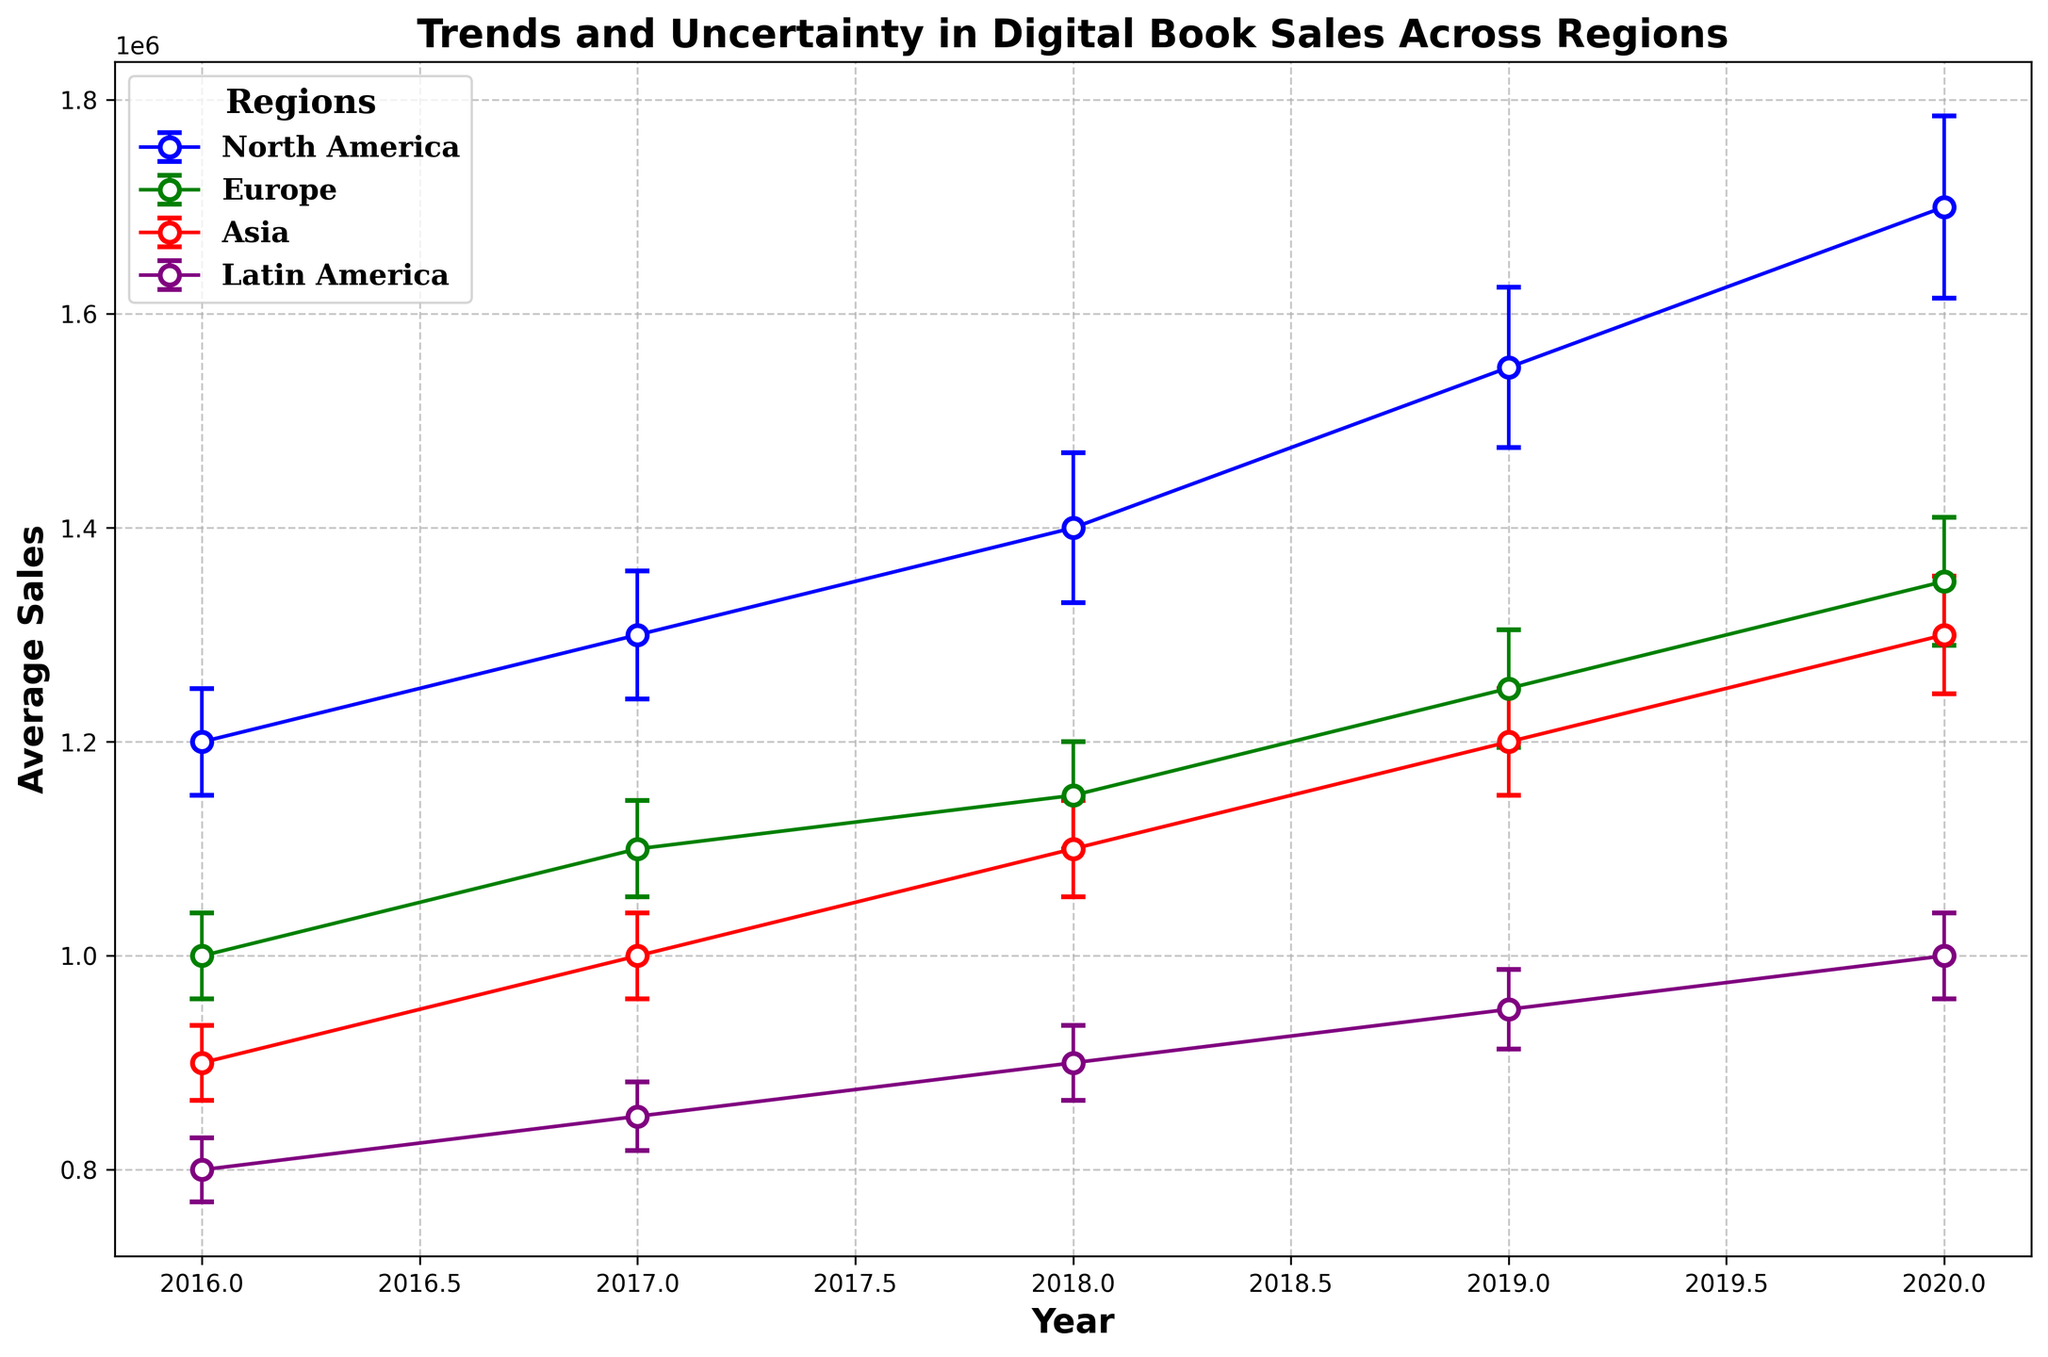How did digital book sales in North America change from 2016 to 2020? North America's sales increased each year from 1,200,000 in 2016 to 1,700,000 in 2020. By examining the figure, you can see a consistent upward trend by following the blue line and marker placement.
Answer: Increased Which region showed the least uncertainty in digital book sales in 2016? By looking at the error bars in the new figure, the region with the smallest uncertainty in 2016 is Latin America, with an error bar length of 30,000. The purple error bar is the shortest for that year compared to others.
Answer: Latin America Did Asia's digital book sales surpass Europe's at any point between 2016 and 2020? By tracking the red line for Asia and the green line for Europe from 2016 to 2020, we see that Europe's sales were consistently higher than Asia's during this period. Consequently, Asia did not surpass Europe in digital book sales.
Answer: No Which year had the highest average uncertainty in digital book sales across all regions? We need to compare the length of error bars for all four regions across the five years. In 2020, North America has 85,000, Europe has 60,000, Asia has 55,000, and Latin America has 40,000, resulting in the highest average uncertainty.
Answer: 2020 What is the difference in average sales between Latin America and North America in 2018? North America's sales in 2018 were 1,400,000, whereas Latin America's were 900,000. Subtracting the two, 1,400,000 - 900,000 gives a difference of 500,000.
Answer: 500,000 Which region experienced the most consistent increase in digital book sales from 2016 to 2020? By examining the trend lines' slopes, Europe's (green) line shows a steady increase with similar increments each year, indicating the most consistent increase.
Answer: Europe What was the trend in digital book sales in Asia from 2016 to 2020, and how did the uncertainty levels change? Asia's sales increased steadily each year from 900,000 to 1,300,000. The uncertainty levels also rose from 35,000 to 55,000, as indicated by increasing error bars on the red line.
Answer: Sales increased; uncertainty also increased In 2019, which region had the smallest uncertainty in digital book sales and what was the average sales figure for that region? In 2019, Latin America had the smallest uncertainty with 37,000. The average sales figure for Latin America in that year was 950,000. The purple error bar is the shortest and the marker sits at 950,000.
Answer: Latin America, 950,000 